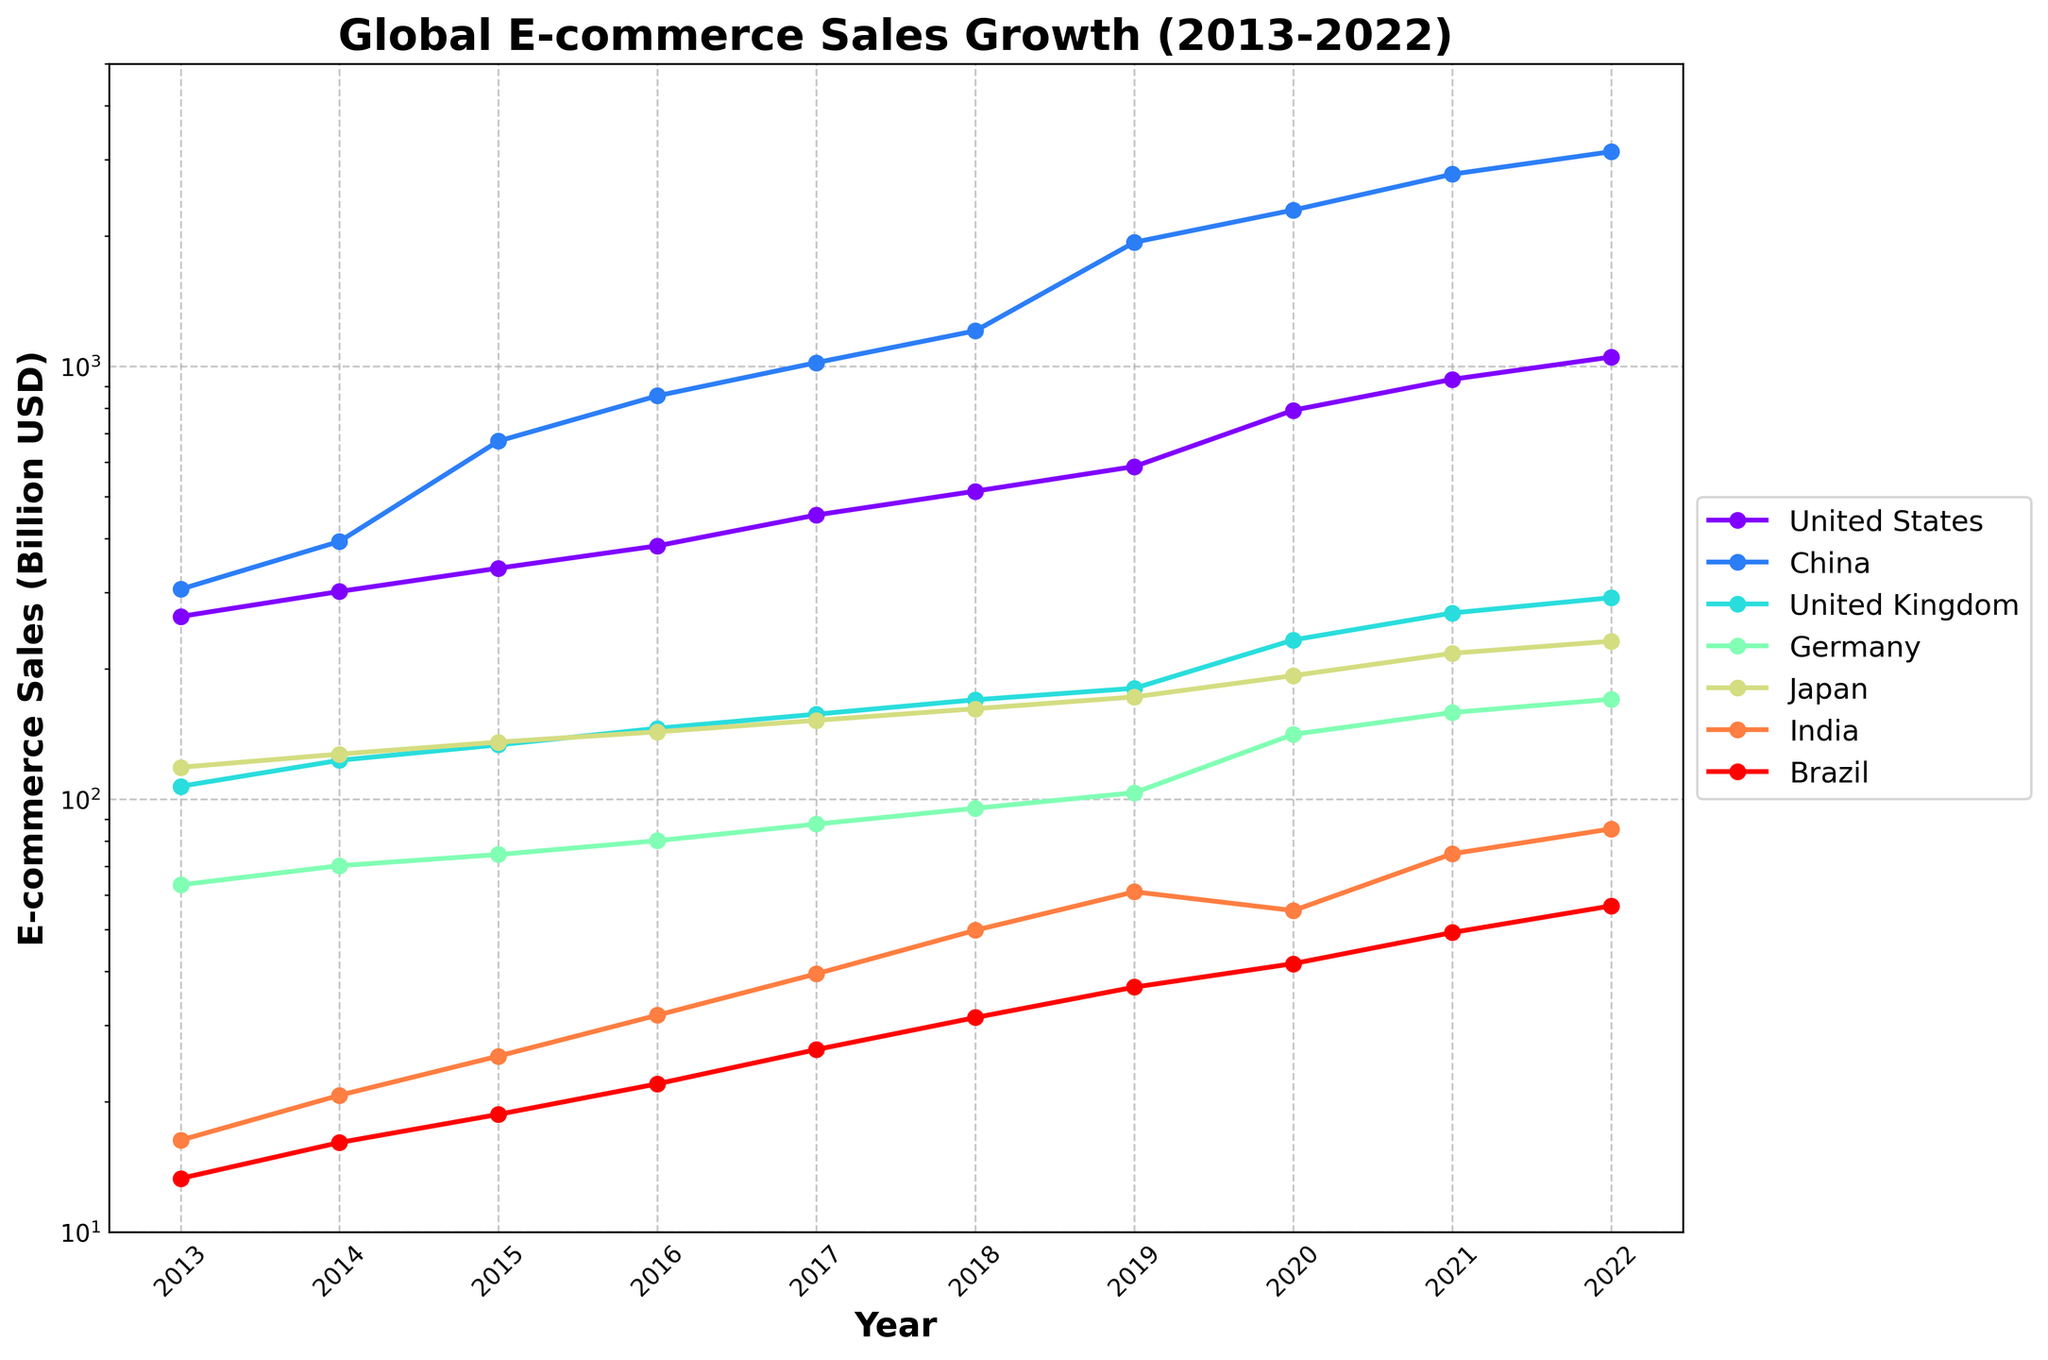What is the total e-commerce sales in the US from 2013 to 2022? Add the yearly sales figures for the US from 2013 to 2022: 264.3 + 301.9 + 341.7 + 384.9 + 453.5 + 514.8 + 586.9 + 791.7 + 933.3 + 1050.9.
Answer: 5624.9 Between which years did China experience the highest growth in e-commerce sales? Identify the years with the largest increase in sales for China by looking at each year's difference: 305.5 to 394.0 (+88.5), 394.0 to 672.0 (+278.0), 672.0 to 855.0 (+183.0), 855.0 to 1020.0 (+165.0), 1020.0 to 1208.0 (+188.0), 1208.0 to 1934.8 (+726.8), 1934.8 to 2297.0 (+362.2), 2297.0 to 2779.3 (+482.3), 2779.3 to 3132.8 (+353.5). The year with the highest difference is between 2018 and 2019.
Answer: 2018-2019 Which country had the lowest e-commerce sales in 2022, and what was the amount? Look at the sales figures for each country in the year 2022 and identify the smallest value: United States (1050.9), China (3132.8), United Kingdom (292.1), Germany (170.2), Japan (231.7), India (85.4), Brazil (56.7). Brazil has the lowest sales.
Answer: Brazil, 56.7 How does the e-commerce sales in India in 2022 compare to Germany's in 2016? Find the sales value for India in 2022 (85.4) and for Germany in 2016 (80.2). Compare the two values: 85.4 > 80.2. India's sales are higher.
Answer: India in 2022 is higher What is the average annual e-commerce growth for Japan from 2016 to 2022? Calculate the annual growth by subtracting the 2016 value from the 2022 value and then dividing by the number of years: (231.7 - 143.1) / (2022 - 2016) = 88.6 / 6 = 14.77.
Answer: 14.77 billion USD per year By what percentage did the United Kingdom's e-commerce sales grow from 2013 to 2022? Calculate the percentage growth by taking the difference between the values in 2022 and 2013, then divide by the 2013 value and multiply by 100: ((292.1 - 107.1) / 107.1) * 100 = 172.79%.
Answer: 172.79% Which year did Brazil see the largest increase in e-commerce sales, and by how much? Calculate the year-to-year differences for Brazil and find the maximum: 13.3 to 16.1 (+2.8), 16.1 to 18.7 (+2.6), 18.7 to 22.0 (+3.3), 22.0 to 26.4 (+4.4), 26.4 to 31.3 (+4.9), 31.3 to 36.8 (+5.5), 36.8 to 41.7 (+4.9), 41.7 to 49.2 (+7.5), 49.2 to 56.7 (+7.5). The largest increase was between 2021 and 2022.
Answer: 2021-2022, 7.5 Which market had the steadiest growth in e-commerce sales over the past decade? Evaluate the consistency of the year-to-year increases for each market by comparing the differences. The United Kingdom demonstrates steady growth with moderate year-to-year increases: United States and China have larger fluctuations, whereas Japan and Brazil have smaller markets.
Answer: United Kingdom What is the ratio of e-commerce sales between China and the US in 2022? Calculate the ratio of sales in 2022 by dividing China's sales by the US's sales: 3132.8 / 1050.9 ≈ 2.98.
Answer: Approximately 3:1 Between which consecutive years did India experience the slowest growth? Calculate the year-to-year growth for India and find the smallest difference: 16.3 to 20.7 (+4.4), 20.7 to 25.5 (+4.8), 25.5 to 31.7 (+6.2), 31.7 to 39.5 (+7.8), 39.5 to 49.8 (+10.3), 49.8 to 61.1 (+11.3), 61.1 to 55.3 (-5.8), 55.3 to 74.8 (+19.5), 74.8 to 85.4 (+10.6). The smallest increase (excluding the decrease) is between 2013 and 2014.
Answer: 2013-2014 